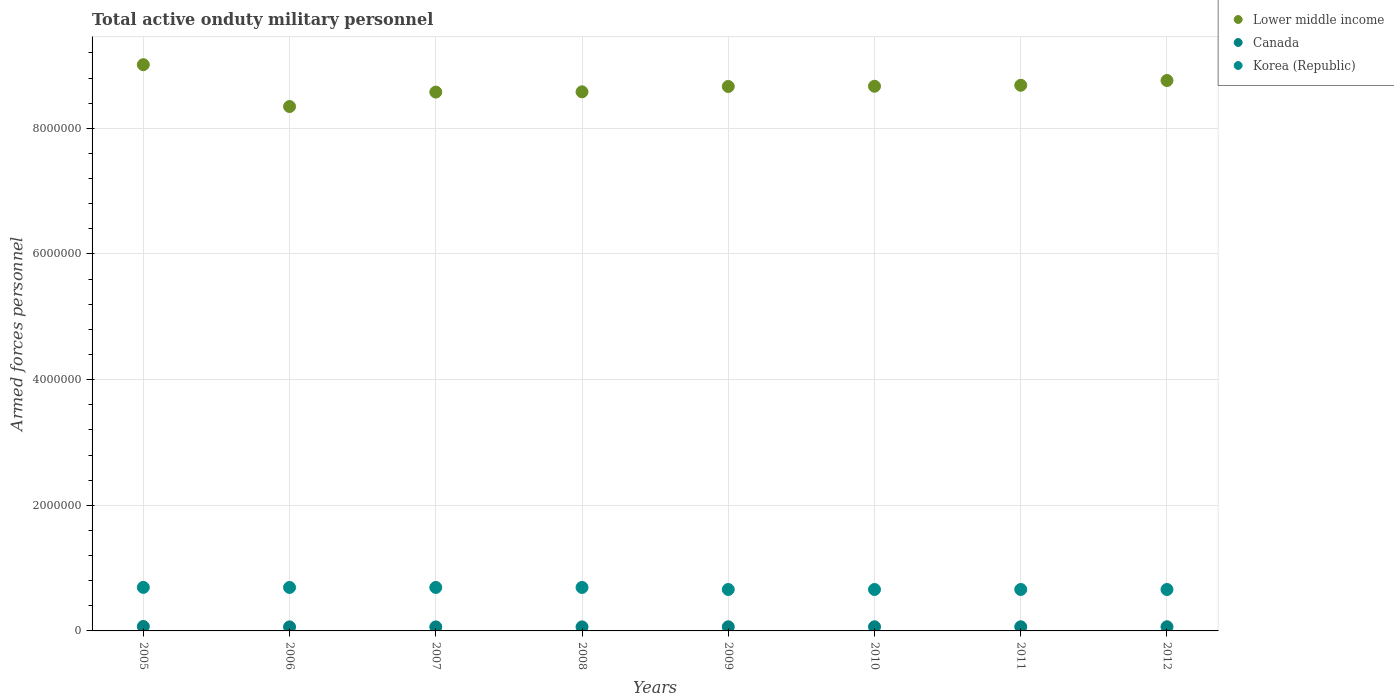How many different coloured dotlines are there?
Offer a terse response. 3. Is the number of dotlines equal to the number of legend labels?
Provide a short and direct response. Yes. What is the number of armed forces personnel in Canada in 2005?
Provide a succinct answer. 7.10e+04. Across all years, what is the maximum number of armed forces personnel in Korea (Republic)?
Ensure brevity in your answer.  6.93e+05. Across all years, what is the minimum number of armed forces personnel in Lower middle income?
Offer a terse response. 8.35e+06. In which year was the number of armed forces personnel in Lower middle income maximum?
Your response must be concise. 2005. What is the total number of armed forces personnel in Korea (Republic) in the graph?
Ensure brevity in your answer.  5.41e+06. What is the difference between the number of armed forces personnel in Canada in 2008 and that in 2009?
Give a very brief answer. -1722. What is the difference between the number of armed forces personnel in Lower middle income in 2012 and the number of armed forces personnel in Korea (Republic) in 2010?
Your answer should be very brief. 8.10e+06. What is the average number of armed forces personnel in Korea (Republic) per year?
Make the answer very short. 6.76e+05. In the year 2010, what is the difference between the number of armed forces personnel in Canada and number of armed forces personnel in Korea (Republic)?
Ensure brevity in your answer.  -5.94e+05. In how many years, is the number of armed forces personnel in Lower middle income greater than 400000?
Your answer should be compact. 8. What is the ratio of the number of armed forces personnel in Lower middle income in 2005 to that in 2008?
Ensure brevity in your answer.  1.05. What is the difference between the highest and the second highest number of armed forces personnel in Korea (Republic)?
Your response must be concise. 1000. What is the difference between the highest and the lowest number of armed forces personnel in Canada?
Provide a succinct answer. 7000. In how many years, is the number of armed forces personnel in Lower middle income greater than the average number of armed forces personnel in Lower middle income taken over all years?
Ensure brevity in your answer.  5. Is the sum of the number of armed forces personnel in Canada in 2009 and 2011 greater than the maximum number of armed forces personnel in Korea (Republic) across all years?
Offer a very short reply. No. Does the number of armed forces personnel in Canada monotonically increase over the years?
Your response must be concise. No. Is the number of armed forces personnel in Canada strictly less than the number of armed forces personnel in Korea (Republic) over the years?
Make the answer very short. Yes. How many years are there in the graph?
Make the answer very short. 8. Are the values on the major ticks of Y-axis written in scientific E-notation?
Keep it short and to the point. No. Where does the legend appear in the graph?
Offer a very short reply. Top right. How are the legend labels stacked?
Offer a terse response. Vertical. What is the title of the graph?
Keep it short and to the point. Total active onduty military personnel. Does "Jordan" appear as one of the legend labels in the graph?
Provide a succinct answer. No. What is the label or title of the Y-axis?
Provide a succinct answer. Armed forces personnel. What is the Armed forces personnel of Lower middle income in 2005?
Your answer should be very brief. 9.01e+06. What is the Armed forces personnel of Canada in 2005?
Keep it short and to the point. 7.10e+04. What is the Armed forces personnel of Korea (Republic) in 2005?
Make the answer very short. 6.93e+05. What is the Armed forces personnel of Lower middle income in 2006?
Keep it short and to the point. 8.35e+06. What is the Armed forces personnel of Canada in 2006?
Offer a very short reply. 6.40e+04. What is the Armed forces personnel of Korea (Republic) in 2006?
Offer a very short reply. 6.92e+05. What is the Armed forces personnel in Lower middle income in 2007?
Provide a short and direct response. 8.58e+06. What is the Armed forces personnel in Canada in 2007?
Your answer should be very brief. 6.40e+04. What is the Armed forces personnel of Korea (Republic) in 2007?
Your answer should be compact. 6.92e+05. What is the Armed forces personnel of Lower middle income in 2008?
Offer a terse response. 8.58e+06. What is the Armed forces personnel in Canada in 2008?
Ensure brevity in your answer.  6.40e+04. What is the Armed forces personnel in Korea (Republic) in 2008?
Ensure brevity in your answer.  6.92e+05. What is the Armed forces personnel in Lower middle income in 2009?
Offer a terse response. 8.67e+06. What is the Armed forces personnel of Canada in 2009?
Your answer should be compact. 6.57e+04. What is the Armed forces personnel of Korea (Republic) in 2009?
Give a very brief answer. 6.60e+05. What is the Armed forces personnel of Lower middle income in 2010?
Keep it short and to the point. 8.67e+06. What is the Armed forces personnel of Canada in 2010?
Offer a very short reply. 6.57e+04. What is the Armed forces personnel in Korea (Republic) in 2010?
Your response must be concise. 6.60e+05. What is the Armed forces personnel of Lower middle income in 2011?
Offer a terse response. 8.69e+06. What is the Armed forces personnel of Canada in 2011?
Offer a very short reply. 6.57e+04. What is the Armed forces personnel in Korea (Republic) in 2011?
Your answer should be very brief. 6.60e+05. What is the Armed forces personnel in Lower middle income in 2012?
Keep it short and to the point. 8.76e+06. What is the Armed forces personnel in Canada in 2012?
Make the answer very short. 6.60e+04. What is the Armed forces personnel in Korea (Republic) in 2012?
Give a very brief answer. 6.60e+05. Across all years, what is the maximum Armed forces personnel of Lower middle income?
Offer a terse response. 9.01e+06. Across all years, what is the maximum Armed forces personnel in Canada?
Your response must be concise. 7.10e+04. Across all years, what is the maximum Armed forces personnel of Korea (Republic)?
Your answer should be very brief. 6.93e+05. Across all years, what is the minimum Armed forces personnel of Lower middle income?
Offer a very short reply. 8.35e+06. Across all years, what is the minimum Armed forces personnel of Canada?
Your answer should be very brief. 6.40e+04. Across all years, what is the minimum Armed forces personnel of Korea (Republic)?
Your answer should be compact. 6.60e+05. What is the total Armed forces personnel of Lower middle income in the graph?
Your response must be concise. 6.93e+07. What is the total Armed forces personnel of Canada in the graph?
Your response must be concise. 5.26e+05. What is the total Armed forces personnel of Korea (Republic) in the graph?
Keep it short and to the point. 5.41e+06. What is the difference between the Armed forces personnel of Lower middle income in 2005 and that in 2006?
Offer a very short reply. 6.66e+05. What is the difference between the Armed forces personnel in Canada in 2005 and that in 2006?
Your answer should be compact. 7000. What is the difference between the Armed forces personnel in Korea (Republic) in 2005 and that in 2006?
Offer a terse response. 1000. What is the difference between the Armed forces personnel of Lower middle income in 2005 and that in 2007?
Provide a short and direct response. 4.36e+05. What is the difference between the Armed forces personnel of Canada in 2005 and that in 2007?
Offer a very short reply. 7000. What is the difference between the Armed forces personnel of Korea (Republic) in 2005 and that in 2007?
Offer a terse response. 1000. What is the difference between the Armed forces personnel in Lower middle income in 2005 and that in 2008?
Make the answer very short. 4.32e+05. What is the difference between the Armed forces personnel in Canada in 2005 and that in 2008?
Offer a terse response. 7000. What is the difference between the Armed forces personnel of Korea (Republic) in 2005 and that in 2008?
Your response must be concise. 1000. What is the difference between the Armed forces personnel of Lower middle income in 2005 and that in 2009?
Provide a succinct answer. 3.47e+05. What is the difference between the Armed forces personnel of Canada in 2005 and that in 2009?
Provide a succinct answer. 5278. What is the difference between the Armed forces personnel in Korea (Republic) in 2005 and that in 2009?
Offer a terse response. 3.35e+04. What is the difference between the Armed forces personnel in Lower middle income in 2005 and that in 2010?
Keep it short and to the point. 3.43e+05. What is the difference between the Armed forces personnel of Canada in 2005 and that in 2010?
Make the answer very short. 5300. What is the difference between the Armed forces personnel in Korea (Republic) in 2005 and that in 2010?
Provide a short and direct response. 3.35e+04. What is the difference between the Armed forces personnel in Lower middle income in 2005 and that in 2011?
Your answer should be compact. 3.28e+05. What is the difference between the Armed forces personnel in Canada in 2005 and that in 2011?
Your answer should be very brief. 5300. What is the difference between the Armed forces personnel of Korea (Republic) in 2005 and that in 2011?
Offer a terse response. 3.35e+04. What is the difference between the Armed forces personnel in Lower middle income in 2005 and that in 2012?
Give a very brief answer. 2.52e+05. What is the difference between the Armed forces personnel in Canada in 2005 and that in 2012?
Provide a succinct answer. 5000. What is the difference between the Armed forces personnel in Korea (Republic) in 2005 and that in 2012?
Offer a terse response. 3.35e+04. What is the difference between the Armed forces personnel of Canada in 2006 and that in 2007?
Give a very brief answer. 0. What is the difference between the Armed forces personnel of Korea (Republic) in 2006 and that in 2007?
Provide a succinct answer. 0. What is the difference between the Armed forces personnel of Lower middle income in 2006 and that in 2008?
Give a very brief answer. -2.34e+05. What is the difference between the Armed forces personnel of Korea (Republic) in 2006 and that in 2008?
Your answer should be very brief. 0. What is the difference between the Armed forces personnel of Lower middle income in 2006 and that in 2009?
Give a very brief answer. -3.19e+05. What is the difference between the Armed forces personnel of Canada in 2006 and that in 2009?
Keep it short and to the point. -1722. What is the difference between the Armed forces personnel of Korea (Republic) in 2006 and that in 2009?
Your response must be concise. 3.25e+04. What is the difference between the Armed forces personnel in Lower middle income in 2006 and that in 2010?
Your answer should be very brief. -3.23e+05. What is the difference between the Armed forces personnel in Canada in 2006 and that in 2010?
Make the answer very short. -1700. What is the difference between the Armed forces personnel in Korea (Republic) in 2006 and that in 2010?
Make the answer very short. 3.25e+04. What is the difference between the Armed forces personnel of Lower middle income in 2006 and that in 2011?
Your answer should be very brief. -3.38e+05. What is the difference between the Armed forces personnel in Canada in 2006 and that in 2011?
Your answer should be very brief. -1700. What is the difference between the Armed forces personnel of Korea (Republic) in 2006 and that in 2011?
Provide a short and direct response. 3.25e+04. What is the difference between the Armed forces personnel in Lower middle income in 2006 and that in 2012?
Give a very brief answer. -4.14e+05. What is the difference between the Armed forces personnel in Canada in 2006 and that in 2012?
Offer a very short reply. -2000. What is the difference between the Armed forces personnel of Korea (Republic) in 2006 and that in 2012?
Your response must be concise. 3.25e+04. What is the difference between the Armed forces personnel in Lower middle income in 2007 and that in 2008?
Keep it short and to the point. -4000. What is the difference between the Armed forces personnel of Lower middle income in 2007 and that in 2009?
Your answer should be very brief. -8.90e+04. What is the difference between the Armed forces personnel of Canada in 2007 and that in 2009?
Offer a very short reply. -1722. What is the difference between the Armed forces personnel in Korea (Republic) in 2007 and that in 2009?
Your answer should be very brief. 3.25e+04. What is the difference between the Armed forces personnel in Lower middle income in 2007 and that in 2010?
Your answer should be compact. -9.25e+04. What is the difference between the Armed forces personnel in Canada in 2007 and that in 2010?
Provide a short and direct response. -1700. What is the difference between the Armed forces personnel in Korea (Republic) in 2007 and that in 2010?
Your answer should be very brief. 3.25e+04. What is the difference between the Armed forces personnel of Lower middle income in 2007 and that in 2011?
Give a very brief answer. -1.08e+05. What is the difference between the Armed forces personnel in Canada in 2007 and that in 2011?
Ensure brevity in your answer.  -1700. What is the difference between the Armed forces personnel in Korea (Republic) in 2007 and that in 2011?
Offer a terse response. 3.25e+04. What is the difference between the Armed forces personnel of Lower middle income in 2007 and that in 2012?
Make the answer very short. -1.84e+05. What is the difference between the Armed forces personnel of Canada in 2007 and that in 2012?
Your answer should be compact. -2000. What is the difference between the Armed forces personnel in Korea (Republic) in 2007 and that in 2012?
Give a very brief answer. 3.25e+04. What is the difference between the Armed forces personnel in Lower middle income in 2008 and that in 2009?
Provide a succinct answer. -8.50e+04. What is the difference between the Armed forces personnel in Canada in 2008 and that in 2009?
Offer a very short reply. -1722. What is the difference between the Armed forces personnel in Korea (Republic) in 2008 and that in 2009?
Provide a short and direct response. 3.25e+04. What is the difference between the Armed forces personnel of Lower middle income in 2008 and that in 2010?
Your answer should be very brief. -8.85e+04. What is the difference between the Armed forces personnel in Canada in 2008 and that in 2010?
Keep it short and to the point. -1700. What is the difference between the Armed forces personnel in Korea (Republic) in 2008 and that in 2010?
Offer a very short reply. 3.25e+04. What is the difference between the Armed forces personnel of Lower middle income in 2008 and that in 2011?
Give a very brief answer. -1.04e+05. What is the difference between the Armed forces personnel in Canada in 2008 and that in 2011?
Your answer should be compact. -1700. What is the difference between the Armed forces personnel of Korea (Republic) in 2008 and that in 2011?
Provide a short and direct response. 3.25e+04. What is the difference between the Armed forces personnel of Lower middle income in 2008 and that in 2012?
Your response must be concise. -1.80e+05. What is the difference between the Armed forces personnel in Canada in 2008 and that in 2012?
Your answer should be very brief. -2000. What is the difference between the Armed forces personnel in Korea (Republic) in 2008 and that in 2012?
Ensure brevity in your answer.  3.25e+04. What is the difference between the Armed forces personnel in Lower middle income in 2009 and that in 2010?
Provide a succinct answer. -3508. What is the difference between the Armed forces personnel of Canada in 2009 and that in 2010?
Ensure brevity in your answer.  22. What is the difference between the Armed forces personnel in Korea (Republic) in 2009 and that in 2010?
Offer a very short reply. 0. What is the difference between the Armed forces personnel of Lower middle income in 2009 and that in 2011?
Ensure brevity in your answer.  -1.93e+04. What is the difference between the Armed forces personnel in Korea (Republic) in 2009 and that in 2011?
Keep it short and to the point. 0. What is the difference between the Armed forces personnel of Lower middle income in 2009 and that in 2012?
Offer a terse response. -9.52e+04. What is the difference between the Armed forces personnel of Canada in 2009 and that in 2012?
Ensure brevity in your answer.  -278. What is the difference between the Armed forces personnel of Lower middle income in 2010 and that in 2011?
Make the answer very short. -1.58e+04. What is the difference between the Armed forces personnel of Canada in 2010 and that in 2011?
Provide a short and direct response. 0. What is the difference between the Armed forces personnel in Lower middle income in 2010 and that in 2012?
Offer a very short reply. -9.16e+04. What is the difference between the Armed forces personnel in Canada in 2010 and that in 2012?
Offer a very short reply. -300. What is the difference between the Armed forces personnel of Lower middle income in 2011 and that in 2012?
Offer a terse response. -7.58e+04. What is the difference between the Armed forces personnel of Canada in 2011 and that in 2012?
Offer a very short reply. -300. What is the difference between the Armed forces personnel in Korea (Republic) in 2011 and that in 2012?
Your answer should be very brief. 0. What is the difference between the Armed forces personnel in Lower middle income in 2005 and the Armed forces personnel in Canada in 2006?
Your answer should be compact. 8.95e+06. What is the difference between the Armed forces personnel of Lower middle income in 2005 and the Armed forces personnel of Korea (Republic) in 2006?
Give a very brief answer. 8.32e+06. What is the difference between the Armed forces personnel of Canada in 2005 and the Armed forces personnel of Korea (Republic) in 2006?
Give a very brief answer. -6.21e+05. What is the difference between the Armed forces personnel of Lower middle income in 2005 and the Armed forces personnel of Canada in 2007?
Offer a terse response. 8.95e+06. What is the difference between the Armed forces personnel of Lower middle income in 2005 and the Armed forces personnel of Korea (Republic) in 2007?
Provide a succinct answer. 8.32e+06. What is the difference between the Armed forces personnel in Canada in 2005 and the Armed forces personnel in Korea (Republic) in 2007?
Ensure brevity in your answer.  -6.21e+05. What is the difference between the Armed forces personnel of Lower middle income in 2005 and the Armed forces personnel of Canada in 2008?
Give a very brief answer. 8.95e+06. What is the difference between the Armed forces personnel of Lower middle income in 2005 and the Armed forces personnel of Korea (Republic) in 2008?
Give a very brief answer. 8.32e+06. What is the difference between the Armed forces personnel in Canada in 2005 and the Armed forces personnel in Korea (Republic) in 2008?
Give a very brief answer. -6.21e+05. What is the difference between the Armed forces personnel of Lower middle income in 2005 and the Armed forces personnel of Canada in 2009?
Your answer should be compact. 8.95e+06. What is the difference between the Armed forces personnel of Lower middle income in 2005 and the Armed forces personnel of Korea (Republic) in 2009?
Your response must be concise. 8.35e+06. What is the difference between the Armed forces personnel in Canada in 2005 and the Armed forces personnel in Korea (Republic) in 2009?
Your answer should be compact. -5.88e+05. What is the difference between the Armed forces personnel of Lower middle income in 2005 and the Armed forces personnel of Canada in 2010?
Your answer should be compact. 8.95e+06. What is the difference between the Armed forces personnel in Lower middle income in 2005 and the Armed forces personnel in Korea (Republic) in 2010?
Your answer should be very brief. 8.35e+06. What is the difference between the Armed forces personnel of Canada in 2005 and the Armed forces personnel of Korea (Republic) in 2010?
Your answer should be very brief. -5.88e+05. What is the difference between the Armed forces personnel of Lower middle income in 2005 and the Armed forces personnel of Canada in 2011?
Keep it short and to the point. 8.95e+06. What is the difference between the Armed forces personnel of Lower middle income in 2005 and the Armed forces personnel of Korea (Republic) in 2011?
Offer a terse response. 8.35e+06. What is the difference between the Armed forces personnel in Canada in 2005 and the Armed forces personnel in Korea (Republic) in 2011?
Ensure brevity in your answer.  -5.88e+05. What is the difference between the Armed forces personnel of Lower middle income in 2005 and the Armed forces personnel of Canada in 2012?
Ensure brevity in your answer.  8.95e+06. What is the difference between the Armed forces personnel in Lower middle income in 2005 and the Armed forces personnel in Korea (Republic) in 2012?
Provide a short and direct response. 8.35e+06. What is the difference between the Armed forces personnel of Canada in 2005 and the Armed forces personnel of Korea (Republic) in 2012?
Your response must be concise. -5.88e+05. What is the difference between the Armed forces personnel in Lower middle income in 2006 and the Armed forces personnel in Canada in 2007?
Provide a succinct answer. 8.28e+06. What is the difference between the Armed forces personnel of Lower middle income in 2006 and the Armed forces personnel of Korea (Republic) in 2007?
Give a very brief answer. 7.66e+06. What is the difference between the Armed forces personnel in Canada in 2006 and the Armed forces personnel in Korea (Republic) in 2007?
Provide a short and direct response. -6.28e+05. What is the difference between the Armed forces personnel in Lower middle income in 2006 and the Armed forces personnel in Canada in 2008?
Make the answer very short. 8.28e+06. What is the difference between the Armed forces personnel of Lower middle income in 2006 and the Armed forces personnel of Korea (Republic) in 2008?
Offer a very short reply. 7.66e+06. What is the difference between the Armed forces personnel of Canada in 2006 and the Armed forces personnel of Korea (Republic) in 2008?
Your response must be concise. -6.28e+05. What is the difference between the Armed forces personnel of Lower middle income in 2006 and the Armed forces personnel of Canada in 2009?
Your answer should be very brief. 8.28e+06. What is the difference between the Armed forces personnel of Lower middle income in 2006 and the Armed forces personnel of Korea (Republic) in 2009?
Provide a short and direct response. 7.69e+06. What is the difference between the Armed forces personnel of Canada in 2006 and the Armed forces personnel of Korea (Republic) in 2009?
Provide a succinct answer. -5.96e+05. What is the difference between the Armed forces personnel in Lower middle income in 2006 and the Armed forces personnel in Canada in 2010?
Your answer should be very brief. 8.28e+06. What is the difference between the Armed forces personnel in Lower middle income in 2006 and the Armed forces personnel in Korea (Republic) in 2010?
Provide a short and direct response. 7.69e+06. What is the difference between the Armed forces personnel of Canada in 2006 and the Armed forces personnel of Korea (Republic) in 2010?
Your answer should be compact. -5.96e+05. What is the difference between the Armed forces personnel in Lower middle income in 2006 and the Armed forces personnel in Canada in 2011?
Ensure brevity in your answer.  8.28e+06. What is the difference between the Armed forces personnel of Lower middle income in 2006 and the Armed forces personnel of Korea (Republic) in 2011?
Keep it short and to the point. 7.69e+06. What is the difference between the Armed forces personnel of Canada in 2006 and the Armed forces personnel of Korea (Republic) in 2011?
Provide a short and direct response. -5.96e+05. What is the difference between the Armed forces personnel of Lower middle income in 2006 and the Armed forces personnel of Canada in 2012?
Provide a short and direct response. 8.28e+06. What is the difference between the Armed forces personnel in Lower middle income in 2006 and the Armed forces personnel in Korea (Republic) in 2012?
Offer a very short reply. 7.69e+06. What is the difference between the Armed forces personnel in Canada in 2006 and the Armed forces personnel in Korea (Republic) in 2012?
Ensure brevity in your answer.  -5.96e+05. What is the difference between the Armed forces personnel of Lower middle income in 2007 and the Armed forces personnel of Canada in 2008?
Keep it short and to the point. 8.51e+06. What is the difference between the Armed forces personnel in Lower middle income in 2007 and the Armed forces personnel in Korea (Republic) in 2008?
Ensure brevity in your answer.  7.88e+06. What is the difference between the Armed forces personnel of Canada in 2007 and the Armed forces personnel of Korea (Republic) in 2008?
Your response must be concise. -6.28e+05. What is the difference between the Armed forces personnel of Lower middle income in 2007 and the Armed forces personnel of Canada in 2009?
Provide a short and direct response. 8.51e+06. What is the difference between the Armed forces personnel in Lower middle income in 2007 and the Armed forces personnel in Korea (Republic) in 2009?
Make the answer very short. 7.92e+06. What is the difference between the Armed forces personnel of Canada in 2007 and the Armed forces personnel of Korea (Republic) in 2009?
Ensure brevity in your answer.  -5.96e+05. What is the difference between the Armed forces personnel of Lower middle income in 2007 and the Armed forces personnel of Canada in 2010?
Your response must be concise. 8.51e+06. What is the difference between the Armed forces personnel of Lower middle income in 2007 and the Armed forces personnel of Korea (Republic) in 2010?
Ensure brevity in your answer.  7.92e+06. What is the difference between the Armed forces personnel in Canada in 2007 and the Armed forces personnel in Korea (Republic) in 2010?
Your answer should be compact. -5.96e+05. What is the difference between the Armed forces personnel of Lower middle income in 2007 and the Armed forces personnel of Canada in 2011?
Your answer should be very brief. 8.51e+06. What is the difference between the Armed forces personnel in Lower middle income in 2007 and the Armed forces personnel in Korea (Republic) in 2011?
Provide a succinct answer. 7.92e+06. What is the difference between the Armed forces personnel of Canada in 2007 and the Armed forces personnel of Korea (Republic) in 2011?
Offer a very short reply. -5.96e+05. What is the difference between the Armed forces personnel of Lower middle income in 2007 and the Armed forces personnel of Canada in 2012?
Give a very brief answer. 8.51e+06. What is the difference between the Armed forces personnel in Lower middle income in 2007 and the Armed forces personnel in Korea (Republic) in 2012?
Make the answer very short. 7.92e+06. What is the difference between the Armed forces personnel in Canada in 2007 and the Armed forces personnel in Korea (Republic) in 2012?
Offer a terse response. -5.96e+05. What is the difference between the Armed forces personnel in Lower middle income in 2008 and the Armed forces personnel in Canada in 2009?
Offer a very short reply. 8.52e+06. What is the difference between the Armed forces personnel of Lower middle income in 2008 and the Armed forces personnel of Korea (Republic) in 2009?
Offer a terse response. 7.92e+06. What is the difference between the Armed forces personnel in Canada in 2008 and the Armed forces personnel in Korea (Republic) in 2009?
Offer a very short reply. -5.96e+05. What is the difference between the Armed forces personnel of Lower middle income in 2008 and the Armed forces personnel of Canada in 2010?
Ensure brevity in your answer.  8.52e+06. What is the difference between the Armed forces personnel of Lower middle income in 2008 and the Armed forces personnel of Korea (Republic) in 2010?
Provide a succinct answer. 7.92e+06. What is the difference between the Armed forces personnel of Canada in 2008 and the Armed forces personnel of Korea (Republic) in 2010?
Ensure brevity in your answer.  -5.96e+05. What is the difference between the Armed forces personnel in Lower middle income in 2008 and the Armed forces personnel in Canada in 2011?
Your answer should be compact. 8.52e+06. What is the difference between the Armed forces personnel in Lower middle income in 2008 and the Armed forces personnel in Korea (Republic) in 2011?
Offer a terse response. 7.92e+06. What is the difference between the Armed forces personnel in Canada in 2008 and the Armed forces personnel in Korea (Republic) in 2011?
Keep it short and to the point. -5.96e+05. What is the difference between the Armed forces personnel of Lower middle income in 2008 and the Armed forces personnel of Canada in 2012?
Your answer should be very brief. 8.52e+06. What is the difference between the Armed forces personnel in Lower middle income in 2008 and the Armed forces personnel in Korea (Republic) in 2012?
Make the answer very short. 7.92e+06. What is the difference between the Armed forces personnel of Canada in 2008 and the Armed forces personnel of Korea (Republic) in 2012?
Your answer should be very brief. -5.96e+05. What is the difference between the Armed forces personnel in Lower middle income in 2009 and the Armed forces personnel in Canada in 2010?
Offer a terse response. 8.60e+06. What is the difference between the Armed forces personnel in Lower middle income in 2009 and the Armed forces personnel in Korea (Republic) in 2010?
Your response must be concise. 8.01e+06. What is the difference between the Armed forces personnel of Canada in 2009 and the Armed forces personnel of Korea (Republic) in 2010?
Provide a succinct answer. -5.94e+05. What is the difference between the Armed forces personnel in Lower middle income in 2009 and the Armed forces personnel in Canada in 2011?
Provide a succinct answer. 8.60e+06. What is the difference between the Armed forces personnel of Lower middle income in 2009 and the Armed forces personnel of Korea (Republic) in 2011?
Your answer should be compact. 8.01e+06. What is the difference between the Armed forces personnel of Canada in 2009 and the Armed forces personnel of Korea (Republic) in 2011?
Offer a very short reply. -5.94e+05. What is the difference between the Armed forces personnel in Lower middle income in 2009 and the Armed forces personnel in Canada in 2012?
Your answer should be compact. 8.60e+06. What is the difference between the Armed forces personnel in Lower middle income in 2009 and the Armed forces personnel in Korea (Republic) in 2012?
Provide a short and direct response. 8.01e+06. What is the difference between the Armed forces personnel of Canada in 2009 and the Armed forces personnel of Korea (Republic) in 2012?
Your answer should be compact. -5.94e+05. What is the difference between the Armed forces personnel of Lower middle income in 2010 and the Armed forces personnel of Canada in 2011?
Offer a terse response. 8.60e+06. What is the difference between the Armed forces personnel in Lower middle income in 2010 and the Armed forces personnel in Korea (Republic) in 2011?
Offer a terse response. 8.01e+06. What is the difference between the Armed forces personnel of Canada in 2010 and the Armed forces personnel of Korea (Republic) in 2011?
Offer a terse response. -5.94e+05. What is the difference between the Armed forces personnel of Lower middle income in 2010 and the Armed forces personnel of Canada in 2012?
Provide a succinct answer. 8.60e+06. What is the difference between the Armed forces personnel of Lower middle income in 2010 and the Armed forces personnel of Korea (Republic) in 2012?
Provide a short and direct response. 8.01e+06. What is the difference between the Armed forces personnel of Canada in 2010 and the Armed forces personnel of Korea (Republic) in 2012?
Ensure brevity in your answer.  -5.94e+05. What is the difference between the Armed forces personnel in Lower middle income in 2011 and the Armed forces personnel in Canada in 2012?
Offer a terse response. 8.62e+06. What is the difference between the Armed forces personnel of Lower middle income in 2011 and the Armed forces personnel of Korea (Republic) in 2012?
Ensure brevity in your answer.  8.03e+06. What is the difference between the Armed forces personnel in Canada in 2011 and the Armed forces personnel in Korea (Republic) in 2012?
Make the answer very short. -5.94e+05. What is the average Armed forces personnel of Lower middle income per year?
Make the answer very short. 8.66e+06. What is the average Armed forces personnel of Canada per year?
Give a very brief answer. 6.58e+04. What is the average Armed forces personnel of Korea (Republic) per year?
Ensure brevity in your answer.  6.76e+05. In the year 2005, what is the difference between the Armed forces personnel in Lower middle income and Armed forces personnel in Canada?
Your answer should be compact. 8.94e+06. In the year 2005, what is the difference between the Armed forces personnel of Lower middle income and Armed forces personnel of Korea (Republic)?
Provide a succinct answer. 8.32e+06. In the year 2005, what is the difference between the Armed forces personnel in Canada and Armed forces personnel in Korea (Republic)?
Give a very brief answer. -6.22e+05. In the year 2006, what is the difference between the Armed forces personnel of Lower middle income and Armed forces personnel of Canada?
Your response must be concise. 8.28e+06. In the year 2006, what is the difference between the Armed forces personnel of Lower middle income and Armed forces personnel of Korea (Republic)?
Offer a terse response. 7.66e+06. In the year 2006, what is the difference between the Armed forces personnel of Canada and Armed forces personnel of Korea (Republic)?
Make the answer very short. -6.28e+05. In the year 2007, what is the difference between the Armed forces personnel in Lower middle income and Armed forces personnel in Canada?
Ensure brevity in your answer.  8.51e+06. In the year 2007, what is the difference between the Armed forces personnel in Lower middle income and Armed forces personnel in Korea (Republic)?
Give a very brief answer. 7.88e+06. In the year 2007, what is the difference between the Armed forces personnel of Canada and Armed forces personnel of Korea (Republic)?
Offer a very short reply. -6.28e+05. In the year 2008, what is the difference between the Armed forces personnel of Lower middle income and Armed forces personnel of Canada?
Give a very brief answer. 8.52e+06. In the year 2008, what is the difference between the Armed forces personnel in Lower middle income and Armed forces personnel in Korea (Republic)?
Keep it short and to the point. 7.89e+06. In the year 2008, what is the difference between the Armed forces personnel in Canada and Armed forces personnel in Korea (Republic)?
Provide a succinct answer. -6.28e+05. In the year 2009, what is the difference between the Armed forces personnel of Lower middle income and Armed forces personnel of Canada?
Your answer should be very brief. 8.60e+06. In the year 2009, what is the difference between the Armed forces personnel in Lower middle income and Armed forces personnel in Korea (Republic)?
Ensure brevity in your answer.  8.01e+06. In the year 2009, what is the difference between the Armed forces personnel in Canada and Armed forces personnel in Korea (Republic)?
Keep it short and to the point. -5.94e+05. In the year 2010, what is the difference between the Armed forces personnel in Lower middle income and Armed forces personnel in Canada?
Your answer should be compact. 8.60e+06. In the year 2010, what is the difference between the Armed forces personnel in Lower middle income and Armed forces personnel in Korea (Republic)?
Make the answer very short. 8.01e+06. In the year 2010, what is the difference between the Armed forces personnel in Canada and Armed forces personnel in Korea (Republic)?
Make the answer very short. -5.94e+05. In the year 2011, what is the difference between the Armed forces personnel in Lower middle income and Armed forces personnel in Canada?
Make the answer very short. 8.62e+06. In the year 2011, what is the difference between the Armed forces personnel in Lower middle income and Armed forces personnel in Korea (Republic)?
Offer a very short reply. 8.03e+06. In the year 2011, what is the difference between the Armed forces personnel of Canada and Armed forces personnel of Korea (Republic)?
Provide a succinct answer. -5.94e+05. In the year 2012, what is the difference between the Armed forces personnel of Lower middle income and Armed forces personnel of Canada?
Provide a short and direct response. 8.70e+06. In the year 2012, what is the difference between the Armed forces personnel in Lower middle income and Armed forces personnel in Korea (Republic)?
Keep it short and to the point. 8.10e+06. In the year 2012, what is the difference between the Armed forces personnel of Canada and Armed forces personnel of Korea (Republic)?
Provide a succinct answer. -5.94e+05. What is the ratio of the Armed forces personnel of Lower middle income in 2005 to that in 2006?
Give a very brief answer. 1.08. What is the ratio of the Armed forces personnel of Canada in 2005 to that in 2006?
Your response must be concise. 1.11. What is the ratio of the Armed forces personnel in Lower middle income in 2005 to that in 2007?
Provide a succinct answer. 1.05. What is the ratio of the Armed forces personnel of Canada in 2005 to that in 2007?
Your answer should be compact. 1.11. What is the ratio of the Armed forces personnel of Korea (Republic) in 2005 to that in 2007?
Keep it short and to the point. 1. What is the ratio of the Armed forces personnel in Lower middle income in 2005 to that in 2008?
Ensure brevity in your answer.  1.05. What is the ratio of the Armed forces personnel of Canada in 2005 to that in 2008?
Offer a very short reply. 1.11. What is the ratio of the Armed forces personnel of Lower middle income in 2005 to that in 2009?
Make the answer very short. 1.04. What is the ratio of the Armed forces personnel in Canada in 2005 to that in 2009?
Ensure brevity in your answer.  1.08. What is the ratio of the Armed forces personnel of Korea (Republic) in 2005 to that in 2009?
Your answer should be compact. 1.05. What is the ratio of the Armed forces personnel in Lower middle income in 2005 to that in 2010?
Give a very brief answer. 1.04. What is the ratio of the Armed forces personnel of Canada in 2005 to that in 2010?
Make the answer very short. 1.08. What is the ratio of the Armed forces personnel of Korea (Republic) in 2005 to that in 2010?
Give a very brief answer. 1.05. What is the ratio of the Armed forces personnel in Lower middle income in 2005 to that in 2011?
Ensure brevity in your answer.  1.04. What is the ratio of the Armed forces personnel of Canada in 2005 to that in 2011?
Offer a terse response. 1.08. What is the ratio of the Armed forces personnel of Korea (Republic) in 2005 to that in 2011?
Provide a short and direct response. 1.05. What is the ratio of the Armed forces personnel in Lower middle income in 2005 to that in 2012?
Make the answer very short. 1.03. What is the ratio of the Armed forces personnel in Canada in 2005 to that in 2012?
Your answer should be very brief. 1.08. What is the ratio of the Armed forces personnel in Korea (Republic) in 2005 to that in 2012?
Offer a terse response. 1.05. What is the ratio of the Armed forces personnel in Lower middle income in 2006 to that in 2007?
Provide a short and direct response. 0.97. What is the ratio of the Armed forces personnel in Lower middle income in 2006 to that in 2008?
Your answer should be very brief. 0.97. What is the ratio of the Armed forces personnel in Korea (Republic) in 2006 to that in 2008?
Your answer should be very brief. 1. What is the ratio of the Armed forces personnel in Lower middle income in 2006 to that in 2009?
Make the answer very short. 0.96. What is the ratio of the Armed forces personnel of Canada in 2006 to that in 2009?
Offer a very short reply. 0.97. What is the ratio of the Armed forces personnel of Korea (Republic) in 2006 to that in 2009?
Provide a succinct answer. 1.05. What is the ratio of the Armed forces personnel in Lower middle income in 2006 to that in 2010?
Offer a very short reply. 0.96. What is the ratio of the Armed forces personnel in Canada in 2006 to that in 2010?
Your answer should be very brief. 0.97. What is the ratio of the Armed forces personnel of Korea (Republic) in 2006 to that in 2010?
Keep it short and to the point. 1.05. What is the ratio of the Armed forces personnel of Canada in 2006 to that in 2011?
Your response must be concise. 0.97. What is the ratio of the Armed forces personnel of Korea (Republic) in 2006 to that in 2011?
Your answer should be very brief. 1.05. What is the ratio of the Armed forces personnel in Lower middle income in 2006 to that in 2012?
Your answer should be very brief. 0.95. What is the ratio of the Armed forces personnel in Canada in 2006 to that in 2012?
Your answer should be compact. 0.97. What is the ratio of the Armed forces personnel in Korea (Republic) in 2006 to that in 2012?
Ensure brevity in your answer.  1.05. What is the ratio of the Armed forces personnel in Korea (Republic) in 2007 to that in 2008?
Provide a short and direct response. 1. What is the ratio of the Armed forces personnel of Lower middle income in 2007 to that in 2009?
Give a very brief answer. 0.99. What is the ratio of the Armed forces personnel in Canada in 2007 to that in 2009?
Your answer should be compact. 0.97. What is the ratio of the Armed forces personnel of Korea (Republic) in 2007 to that in 2009?
Make the answer very short. 1.05. What is the ratio of the Armed forces personnel of Lower middle income in 2007 to that in 2010?
Offer a terse response. 0.99. What is the ratio of the Armed forces personnel in Canada in 2007 to that in 2010?
Offer a terse response. 0.97. What is the ratio of the Armed forces personnel in Korea (Republic) in 2007 to that in 2010?
Offer a terse response. 1.05. What is the ratio of the Armed forces personnel of Lower middle income in 2007 to that in 2011?
Keep it short and to the point. 0.99. What is the ratio of the Armed forces personnel in Canada in 2007 to that in 2011?
Your answer should be very brief. 0.97. What is the ratio of the Armed forces personnel of Korea (Republic) in 2007 to that in 2011?
Provide a succinct answer. 1.05. What is the ratio of the Armed forces personnel in Canada in 2007 to that in 2012?
Keep it short and to the point. 0.97. What is the ratio of the Armed forces personnel in Korea (Republic) in 2007 to that in 2012?
Keep it short and to the point. 1.05. What is the ratio of the Armed forces personnel of Lower middle income in 2008 to that in 2009?
Ensure brevity in your answer.  0.99. What is the ratio of the Armed forces personnel in Canada in 2008 to that in 2009?
Your answer should be very brief. 0.97. What is the ratio of the Armed forces personnel of Korea (Republic) in 2008 to that in 2009?
Offer a terse response. 1.05. What is the ratio of the Armed forces personnel of Canada in 2008 to that in 2010?
Give a very brief answer. 0.97. What is the ratio of the Armed forces personnel of Korea (Republic) in 2008 to that in 2010?
Your answer should be very brief. 1.05. What is the ratio of the Armed forces personnel of Canada in 2008 to that in 2011?
Keep it short and to the point. 0.97. What is the ratio of the Armed forces personnel in Korea (Republic) in 2008 to that in 2011?
Give a very brief answer. 1.05. What is the ratio of the Armed forces personnel in Lower middle income in 2008 to that in 2012?
Your answer should be compact. 0.98. What is the ratio of the Armed forces personnel of Canada in 2008 to that in 2012?
Give a very brief answer. 0.97. What is the ratio of the Armed forces personnel in Korea (Republic) in 2008 to that in 2012?
Keep it short and to the point. 1.05. What is the ratio of the Armed forces personnel in Lower middle income in 2009 to that in 2010?
Your response must be concise. 1. What is the ratio of the Armed forces personnel in Canada in 2009 to that in 2010?
Ensure brevity in your answer.  1. What is the ratio of the Armed forces personnel of Korea (Republic) in 2009 to that in 2010?
Offer a terse response. 1. What is the ratio of the Armed forces personnel in Lower middle income in 2009 to that in 2011?
Keep it short and to the point. 1. What is the ratio of the Armed forces personnel in Lower middle income in 2010 to that in 2011?
Keep it short and to the point. 1. What is the ratio of the Armed forces personnel in Canada in 2010 to that in 2011?
Keep it short and to the point. 1. What is the ratio of the Armed forces personnel in Lower middle income in 2010 to that in 2012?
Ensure brevity in your answer.  0.99. What is the ratio of the Armed forces personnel in Canada in 2010 to that in 2012?
Make the answer very short. 1. What is the ratio of the Armed forces personnel of Korea (Republic) in 2010 to that in 2012?
Make the answer very short. 1. What is the ratio of the Armed forces personnel of Lower middle income in 2011 to that in 2012?
Give a very brief answer. 0.99. What is the ratio of the Armed forces personnel in Canada in 2011 to that in 2012?
Give a very brief answer. 1. What is the difference between the highest and the second highest Armed forces personnel of Lower middle income?
Give a very brief answer. 2.52e+05. What is the difference between the highest and the lowest Armed forces personnel of Lower middle income?
Provide a short and direct response. 6.66e+05. What is the difference between the highest and the lowest Armed forces personnel in Canada?
Offer a terse response. 7000. What is the difference between the highest and the lowest Armed forces personnel in Korea (Republic)?
Your answer should be very brief. 3.35e+04. 